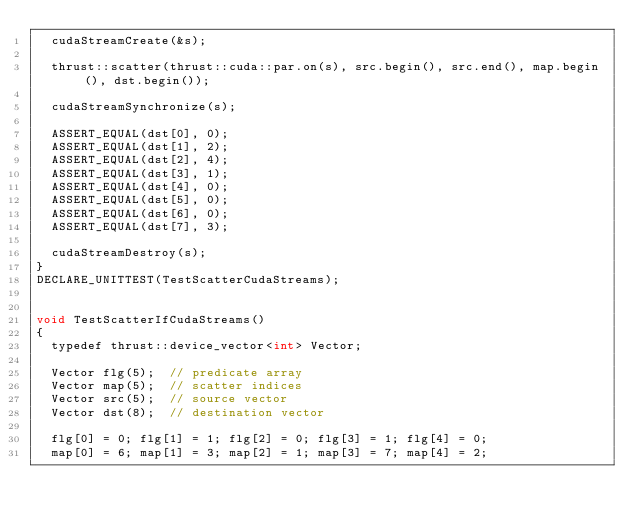Convert code to text. <code><loc_0><loc_0><loc_500><loc_500><_Cuda_>  cudaStreamCreate(&s);

  thrust::scatter(thrust::cuda::par.on(s), src.begin(), src.end(), map.begin(), dst.begin());

  cudaStreamSynchronize(s);

  ASSERT_EQUAL(dst[0], 0);
  ASSERT_EQUAL(dst[1], 2);
  ASSERT_EQUAL(dst[2], 4);
  ASSERT_EQUAL(dst[3], 1);
  ASSERT_EQUAL(dst[4], 0);
  ASSERT_EQUAL(dst[5], 0);
  ASSERT_EQUAL(dst[6], 0);
  ASSERT_EQUAL(dst[7], 3);

  cudaStreamDestroy(s);
}
DECLARE_UNITTEST(TestScatterCudaStreams);


void TestScatterIfCudaStreams()
{
  typedef thrust::device_vector<int> Vector;
  
  Vector flg(5);  // predicate array
  Vector map(5);  // scatter indices
  Vector src(5);  // source vector
  Vector dst(8);  // destination vector
  
  flg[0] = 0; flg[1] = 1; flg[2] = 0; flg[3] = 1; flg[4] = 0;
  map[0] = 6; map[1] = 3; map[2] = 1; map[3] = 7; map[4] = 2;</code> 